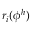<formula> <loc_0><loc_0><loc_500><loc_500>r _ { i } ( \phi ^ { h } )</formula> 